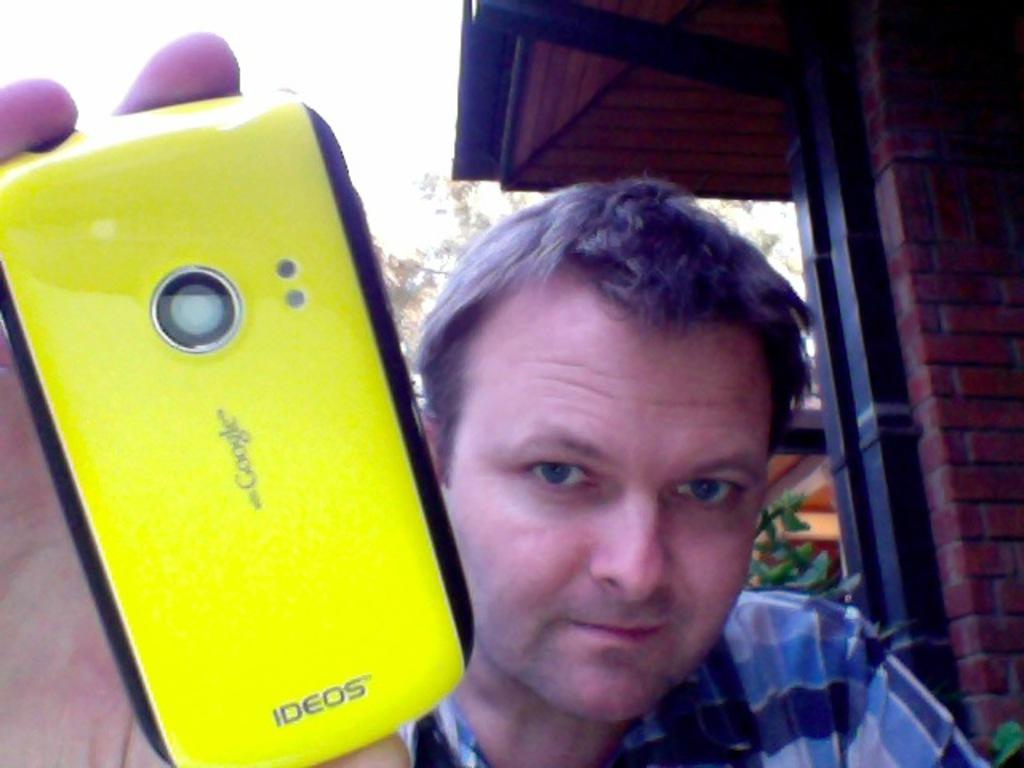What is the main subject of the image? There is a man in the image. What is the man doing in the image? The man is standing. What object is the man holding in his hand? The man is holding a mobile phone in his hand. What type of servant is standing next to the man in the image? There is no servant present in the image; it only features a man standing and holding a mobile phone. What kind of spot can be seen on the man's shirt in the image? There is no spot visible on the man's shirt in the image. 